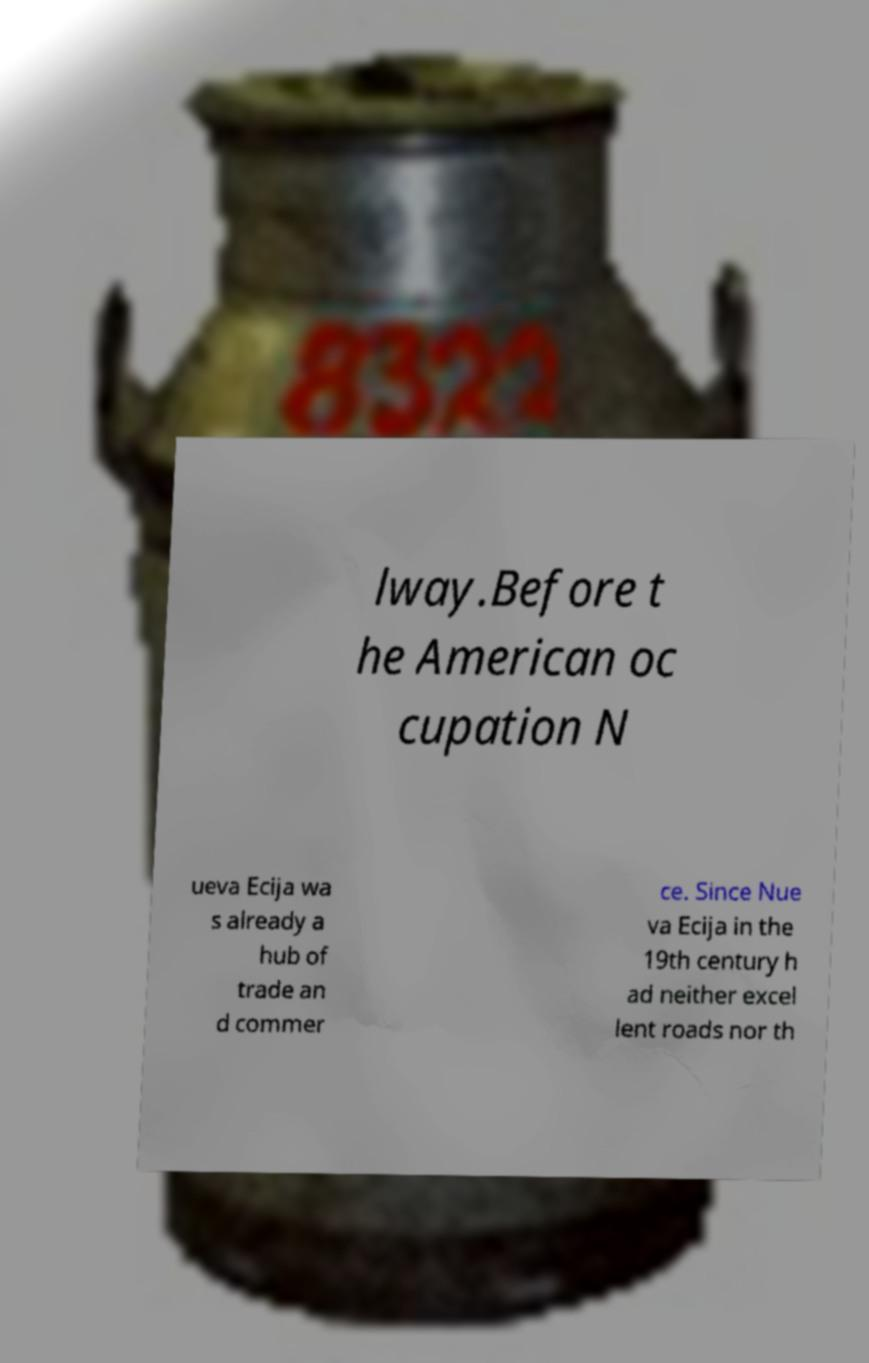Could you assist in decoding the text presented in this image and type it out clearly? lway.Before t he American oc cupation N ueva Ecija wa s already a hub of trade an d commer ce. Since Nue va Ecija in the 19th century h ad neither excel lent roads nor th 